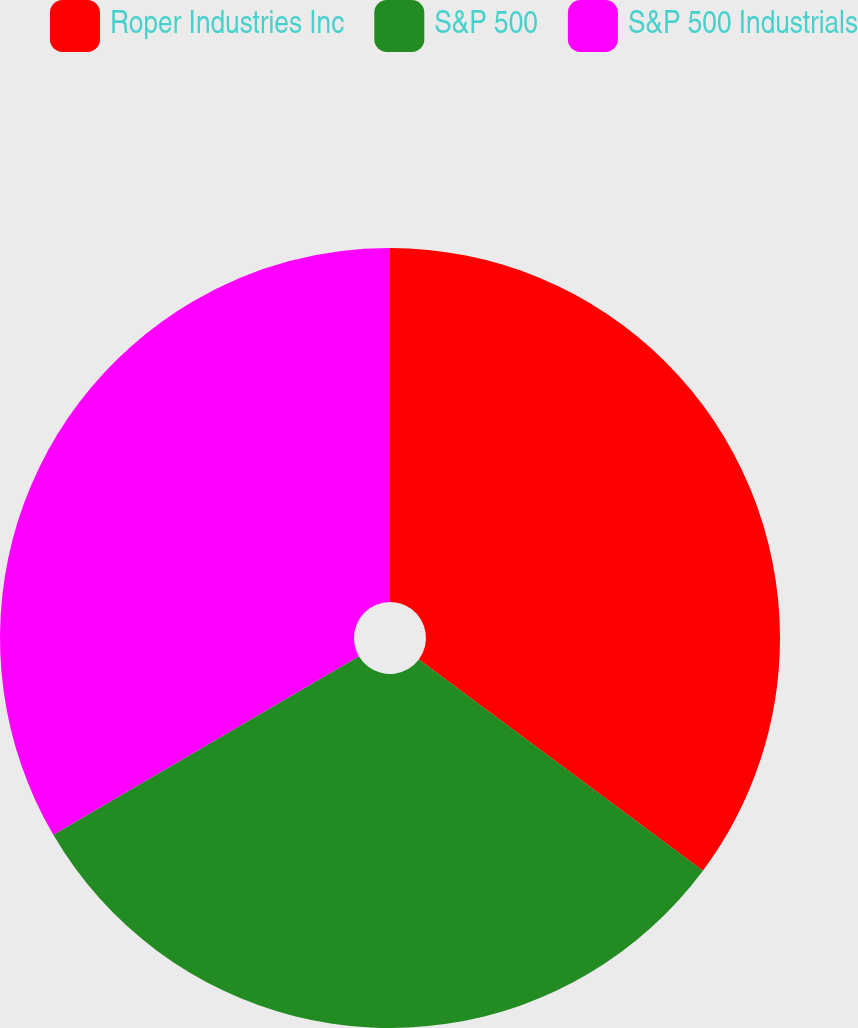Convert chart. <chart><loc_0><loc_0><loc_500><loc_500><pie_chart><fcel>Roper Industries Inc<fcel>S&P 500<fcel>S&P 500 Industrials<nl><fcel>35.18%<fcel>31.4%<fcel>33.42%<nl></chart> 